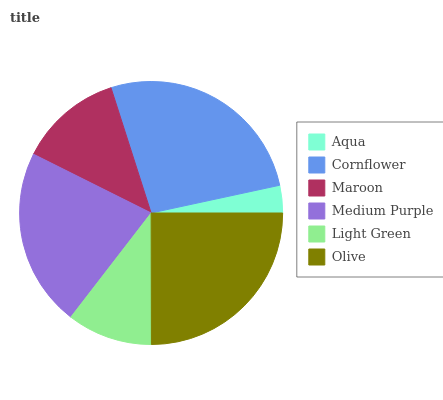Is Aqua the minimum?
Answer yes or no. Yes. Is Cornflower the maximum?
Answer yes or no. Yes. Is Maroon the minimum?
Answer yes or no. No. Is Maroon the maximum?
Answer yes or no. No. Is Cornflower greater than Maroon?
Answer yes or no. Yes. Is Maroon less than Cornflower?
Answer yes or no. Yes. Is Maroon greater than Cornflower?
Answer yes or no. No. Is Cornflower less than Maroon?
Answer yes or no. No. Is Medium Purple the high median?
Answer yes or no. Yes. Is Maroon the low median?
Answer yes or no. Yes. Is Light Green the high median?
Answer yes or no. No. Is Olive the low median?
Answer yes or no. No. 